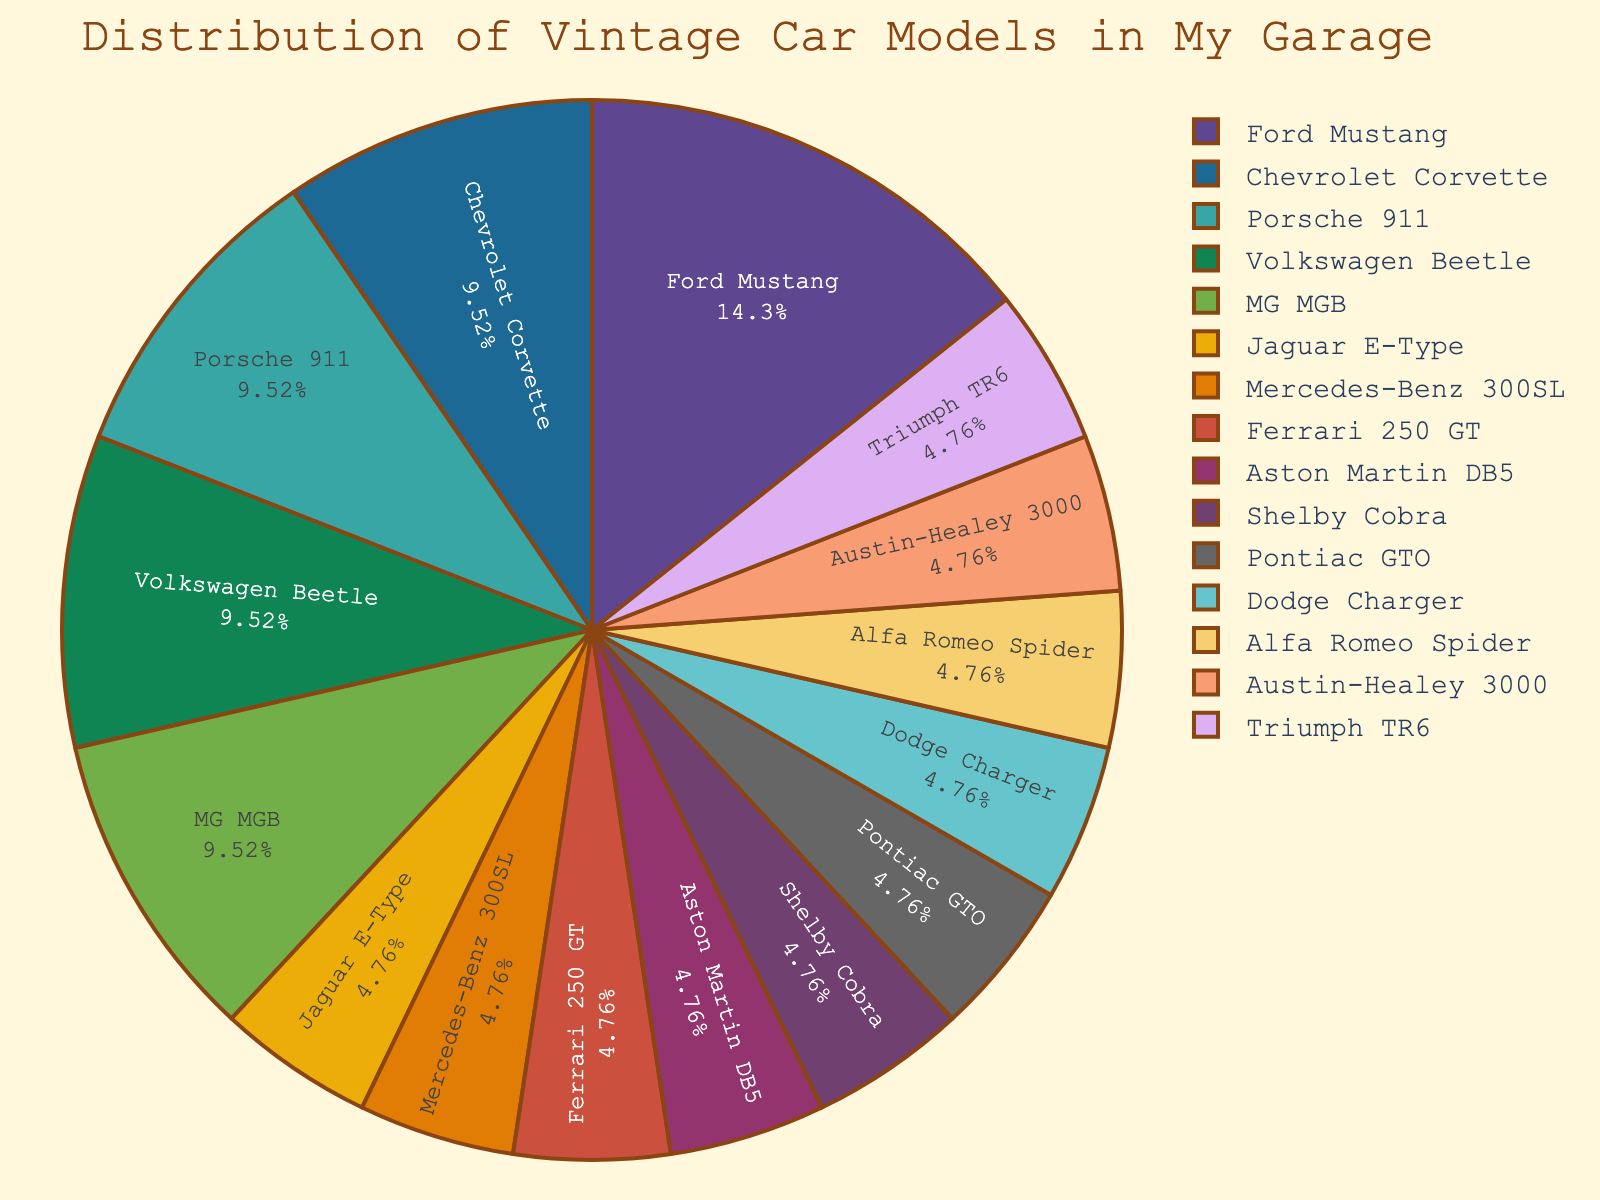What is the most common vintage car model in your garage? The most common car model is represented by the largest slice in the pie chart. The Ford Mustang, being the largest slice, indicates it has the highest count.
Answer: Ford Mustang Which car models have the same count in the garage? To answer this, identify car models that have equally sized slices. Both the Porsche 911 and MG MGB as well as the Chevrolet Corvette and Volkswagen Beetle each have identical slice sizes, which translates to the same count.
Answer: Porsche 911 and MG MGB, Chevrolet Corvette and Volkswagen Beetle How does the count of Ford Mustangs compare to Chevrolet Corvettes in your collection? Compare the sizes of the slices representing the Ford Mustang and Chevrolet Corvette. The Ford Mustang slice is larger, indicating it has a higher count. Specifically, the Ford Mustang (3) compared to the Chevrolet Corvette (2).
Answer: Ford Mustang has more What percentage of your collection is made up of Jaguar E-Type, Mercedes-Benz 300SL, and Ferrari 250 GT combined? Sum the counts of Jaguar E-Type, Mercedes-Benz 300SL, and Ferrari 250 GT (1 each, totaling 3). Divide this sum by the total number of cars (20), then multiply by 100 to get the percentage: (3/20) * 100 = 15%.
Answer: 15% What proportion of the total collection consists of only unique car models? Unique car models are those with a count of 1. Count these slices in the pie chart (Jaguar E-Type, Mercedes-Benz 300SL, Ferrari 250 GT, Aston Martin DB5, Shelby Cobra, Pontiac GTO, Dodge Charger, Alfa Romeo Spider, Austin-Healey 3000, and Triumph TR6), totaling 10. Divide by the total number of cars (20): 10/20 = 0.5, or 50%.
Answer: 50% How many car models have counts greater than 1? Identify the slices larger than those representing a count of 1. The models are Ford Mustang, Chevrolet Corvette, Porsche 911, Volkswagen Beetle, and MG MGB, which total to 5 models.
Answer: 5 models Which car model represents the smallest percentage of your garage? The smallest slice in the pie chart represents the car with the lowest count relative to the others. Since several models are tied with a count of 1, they share the smallest percentage, but each of these models represents 5% of the total collection.
Answer: Jaguar E-Type, Mercedes-Benz 300SL, Ferrari 250 GT, Aston Martin DB5, Shelby Cobra, Pontiac GTO, Dodge Charger, Alfa Romeo Spider, Austin-Healey 3000, Triumph TR6 